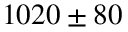Convert formula to latex. <formula><loc_0><loc_0><loc_500><loc_500>1 0 2 0 \pm 8 0</formula> 